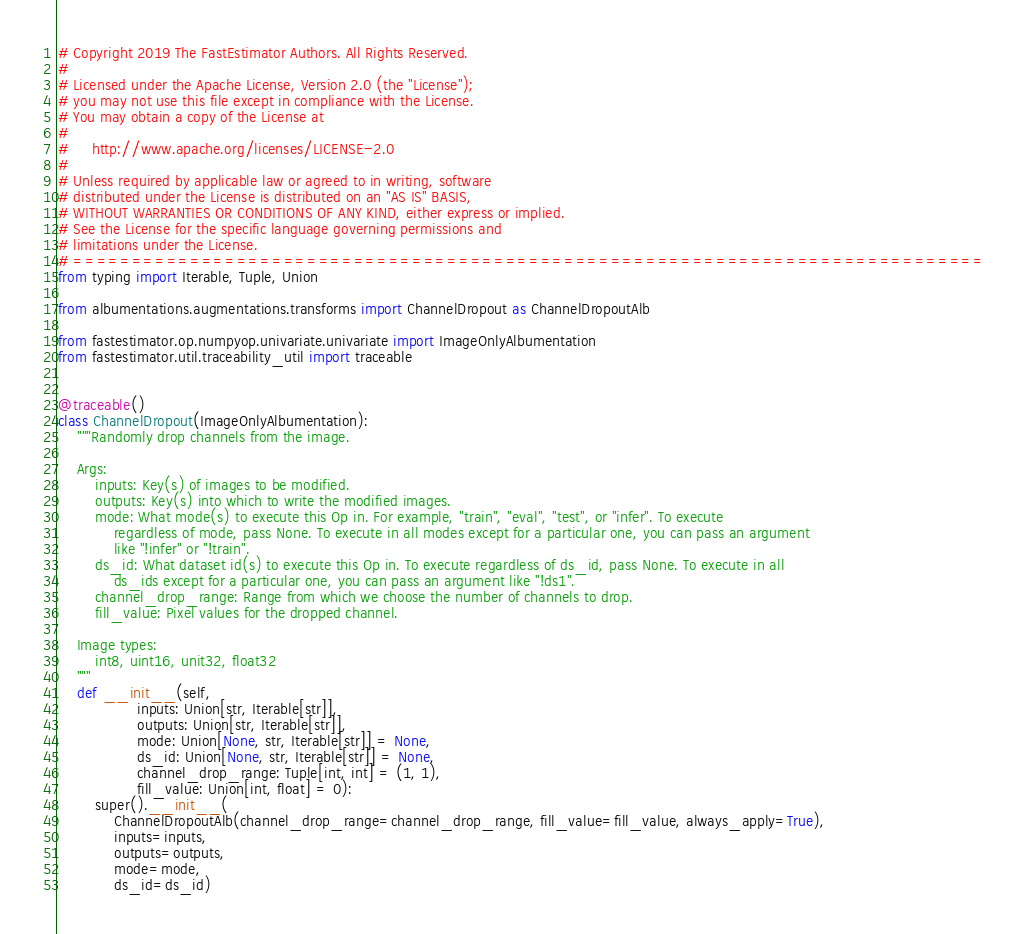Convert code to text. <code><loc_0><loc_0><loc_500><loc_500><_Python_># Copyright 2019 The FastEstimator Authors. All Rights Reserved.
#
# Licensed under the Apache License, Version 2.0 (the "License");
# you may not use this file except in compliance with the License.
# You may obtain a copy of the License at
#
#     http://www.apache.org/licenses/LICENSE-2.0
#
# Unless required by applicable law or agreed to in writing, software
# distributed under the License is distributed on an "AS IS" BASIS,
# WITHOUT WARRANTIES OR CONDITIONS OF ANY KIND, either express or implied.
# See the License for the specific language governing permissions and
# limitations under the License.
# ==============================================================================
from typing import Iterable, Tuple, Union

from albumentations.augmentations.transforms import ChannelDropout as ChannelDropoutAlb

from fastestimator.op.numpyop.univariate.univariate import ImageOnlyAlbumentation
from fastestimator.util.traceability_util import traceable


@traceable()
class ChannelDropout(ImageOnlyAlbumentation):
    """Randomly drop channels from the image.

    Args:
        inputs: Key(s) of images to be modified.
        outputs: Key(s) into which to write the modified images.
        mode: What mode(s) to execute this Op in. For example, "train", "eval", "test", or "infer". To execute
            regardless of mode, pass None. To execute in all modes except for a particular one, you can pass an argument
            like "!infer" or "!train".
        ds_id: What dataset id(s) to execute this Op in. To execute regardless of ds_id, pass None. To execute in all
            ds_ids except for a particular one, you can pass an argument like "!ds1".
        channel_drop_range: Range from which we choose the number of channels to drop.
        fill_value: Pixel values for the dropped channel.

    Image types:
        int8, uint16, unit32, float32
    """
    def __init__(self,
                 inputs: Union[str, Iterable[str]],
                 outputs: Union[str, Iterable[str]],
                 mode: Union[None, str, Iterable[str]] = None,
                 ds_id: Union[None, str, Iterable[str]] = None,
                 channel_drop_range: Tuple[int, int] = (1, 1),
                 fill_value: Union[int, float] = 0):
        super().__init__(
            ChannelDropoutAlb(channel_drop_range=channel_drop_range, fill_value=fill_value, always_apply=True),
            inputs=inputs,
            outputs=outputs,
            mode=mode,
            ds_id=ds_id)
</code> 